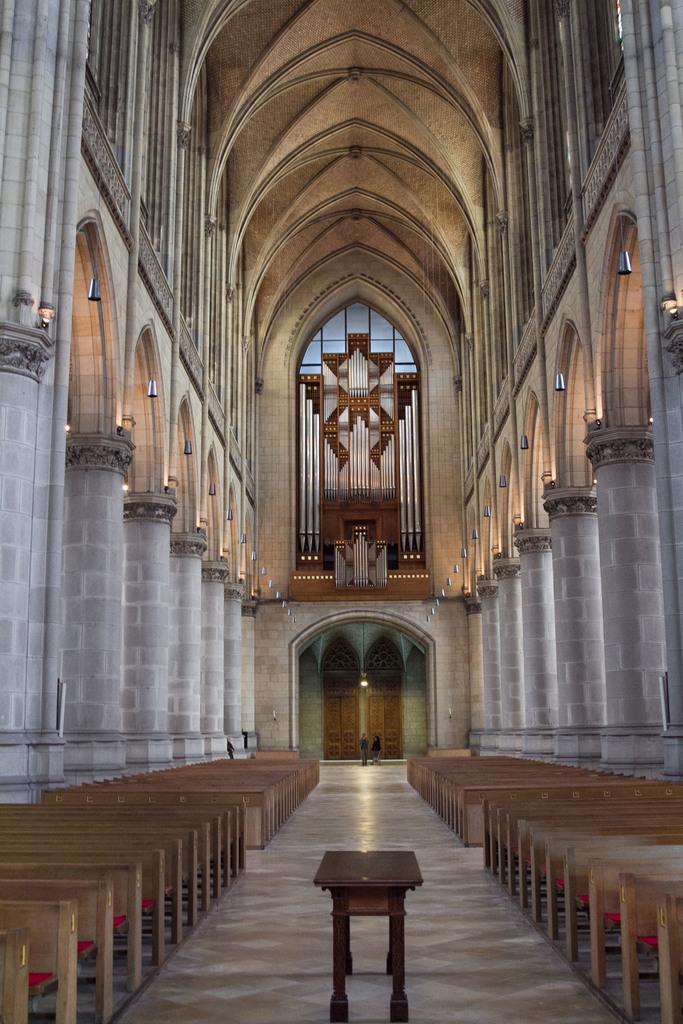Can you describe this image briefly? At the bottom of the image we can see some beaches. In the middle of the we can see some pillars. At the top of the image we the roof. 